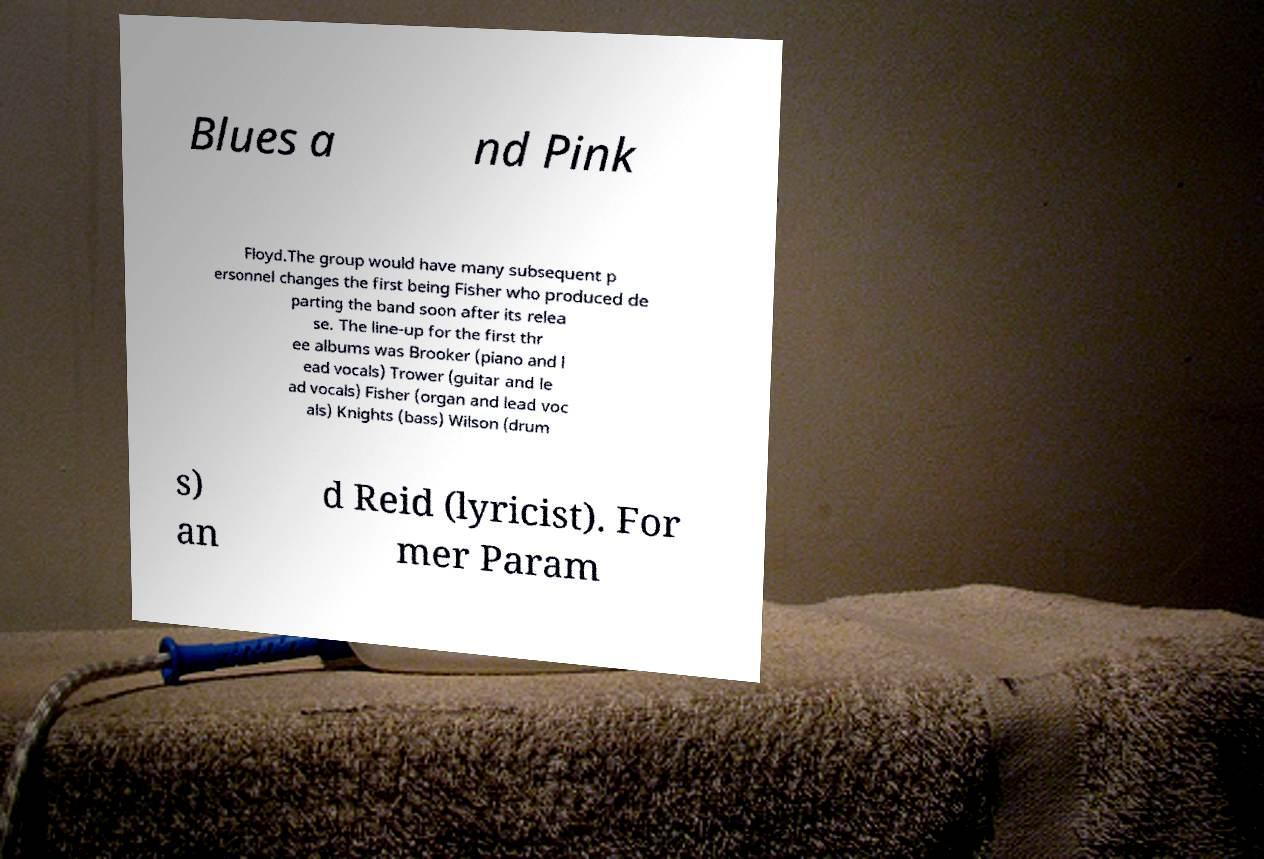There's text embedded in this image that I need extracted. Can you transcribe it verbatim? Blues a nd Pink Floyd.The group would have many subsequent p ersonnel changes the first being Fisher who produced de parting the band soon after its relea se. The line-up for the first thr ee albums was Brooker (piano and l ead vocals) Trower (guitar and le ad vocals) Fisher (organ and lead voc als) Knights (bass) Wilson (drum s) an d Reid (lyricist). For mer Param 